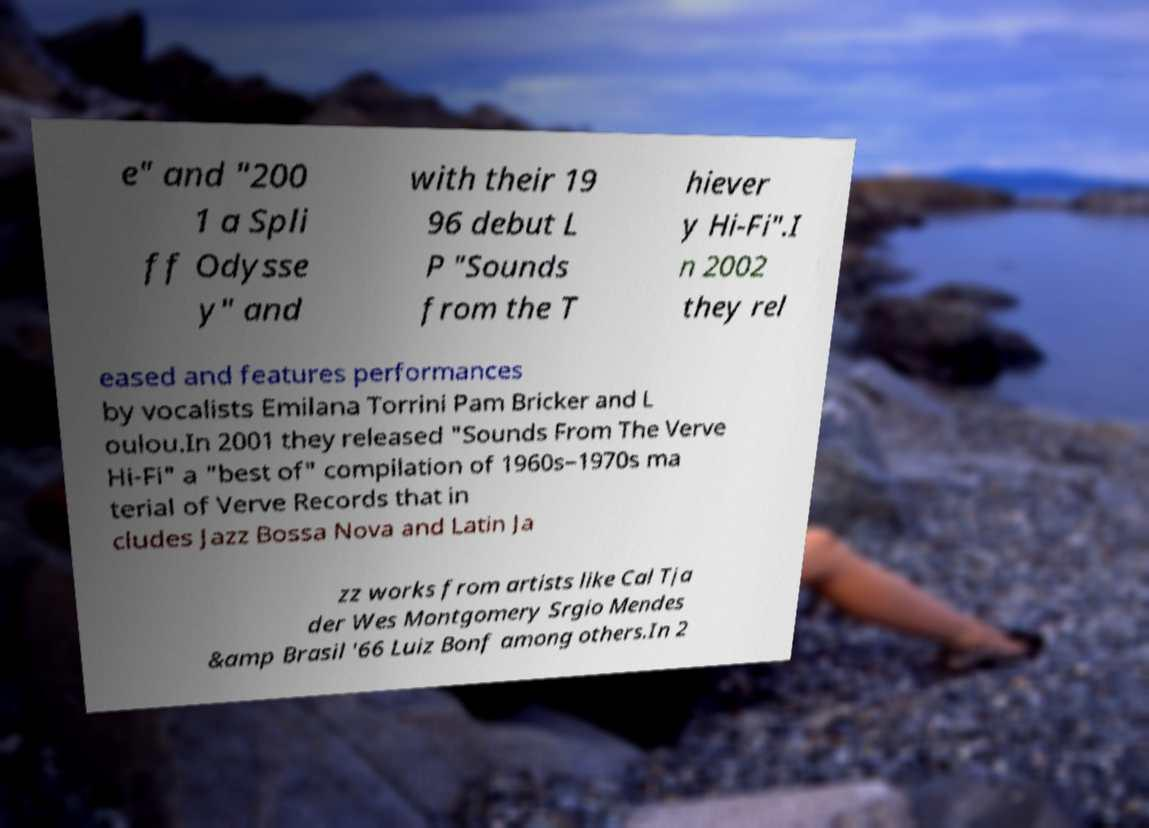There's text embedded in this image that I need extracted. Can you transcribe it verbatim? e" and "200 1 a Spli ff Odysse y" and with their 19 96 debut L P "Sounds from the T hiever y Hi-Fi".I n 2002 they rel eased and features performances by vocalists Emilana Torrini Pam Bricker and L oulou.In 2001 they released "Sounds From The Verve Hi-Fi" a "best of" compilation of 1960s–1970s ma terial of Verve Records that in cludes Jazz Bossa Nova and Latin Ja zz works from artists like Cal Tja der Wes Montgomery Srgio Mendes &amp Brasil '66 Luiz Bonf among others.In 2 